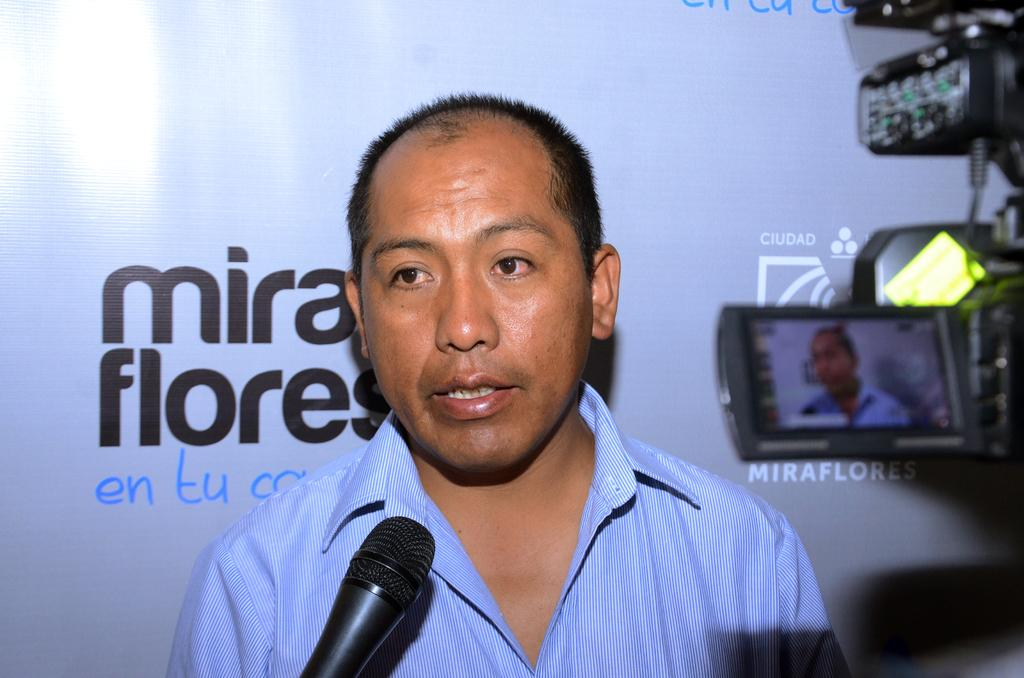Who or what is the main subject in the image? There is a person in the image. What object is in front of the person? There is a microphone in front of the person. What can be seen on the right side of the image? There is a camera on the right side of the image. What is visible in the background of the image? There is a banner with text in the background of the image. Can you see the person's mom holding a kitten in the image? There is no person's mom or kitten present in the image. 